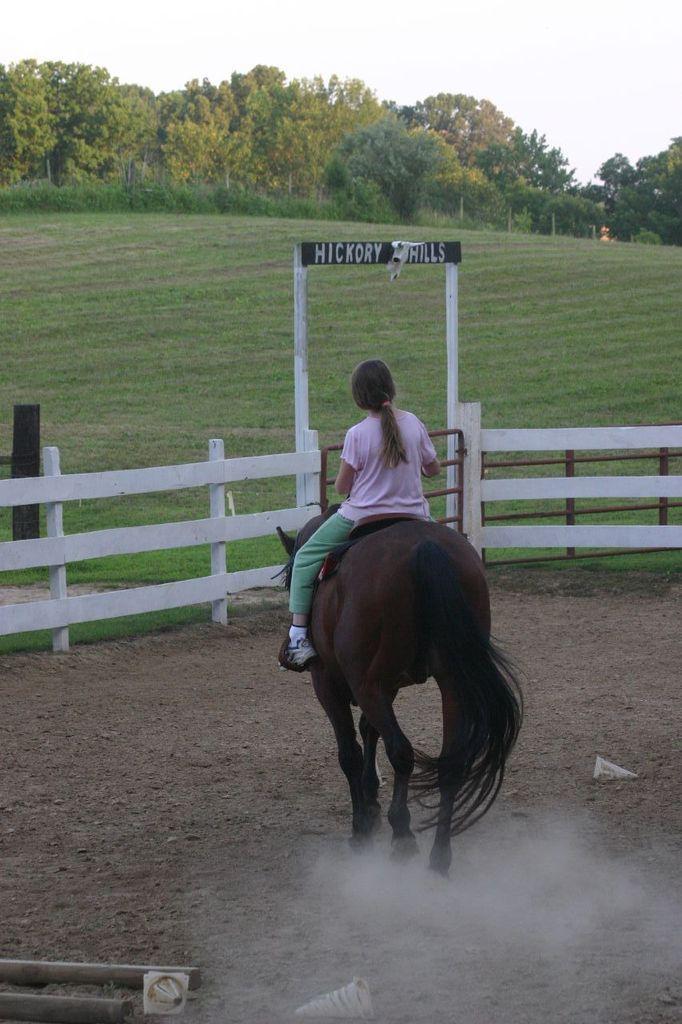How would you summarize this image in a sentence or two? Here we can see a girl sitting on a horse and in front of her there is a wooden railing and trees present 